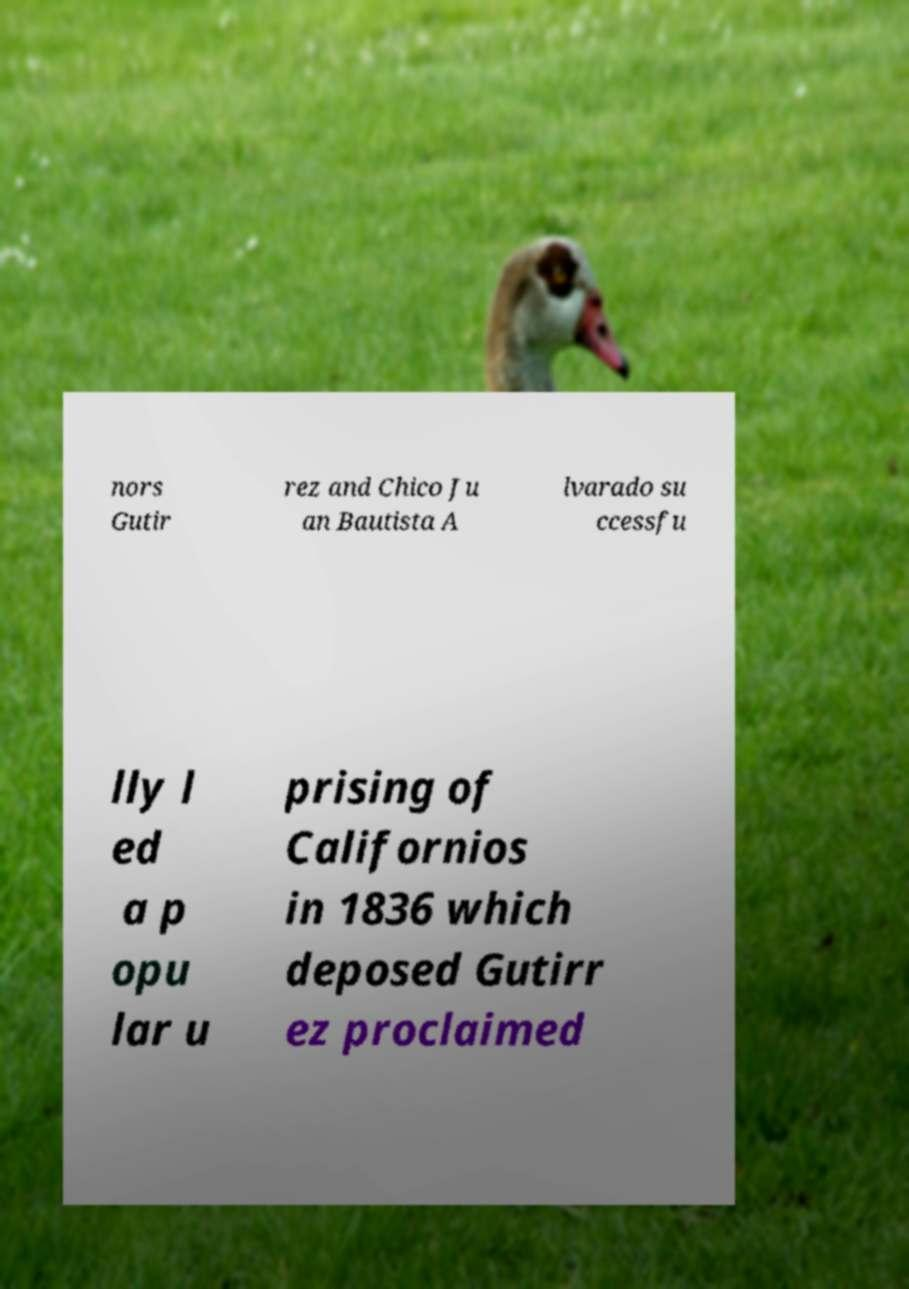Please read and relay the text visible in this image. What does it say? nors Gutir rez and Chico Ju an Bautista A lvarado su ccessfu lly l ed a p opu lar u prising of Californios in 1836 which deposed Gutirr ez proclaimed 